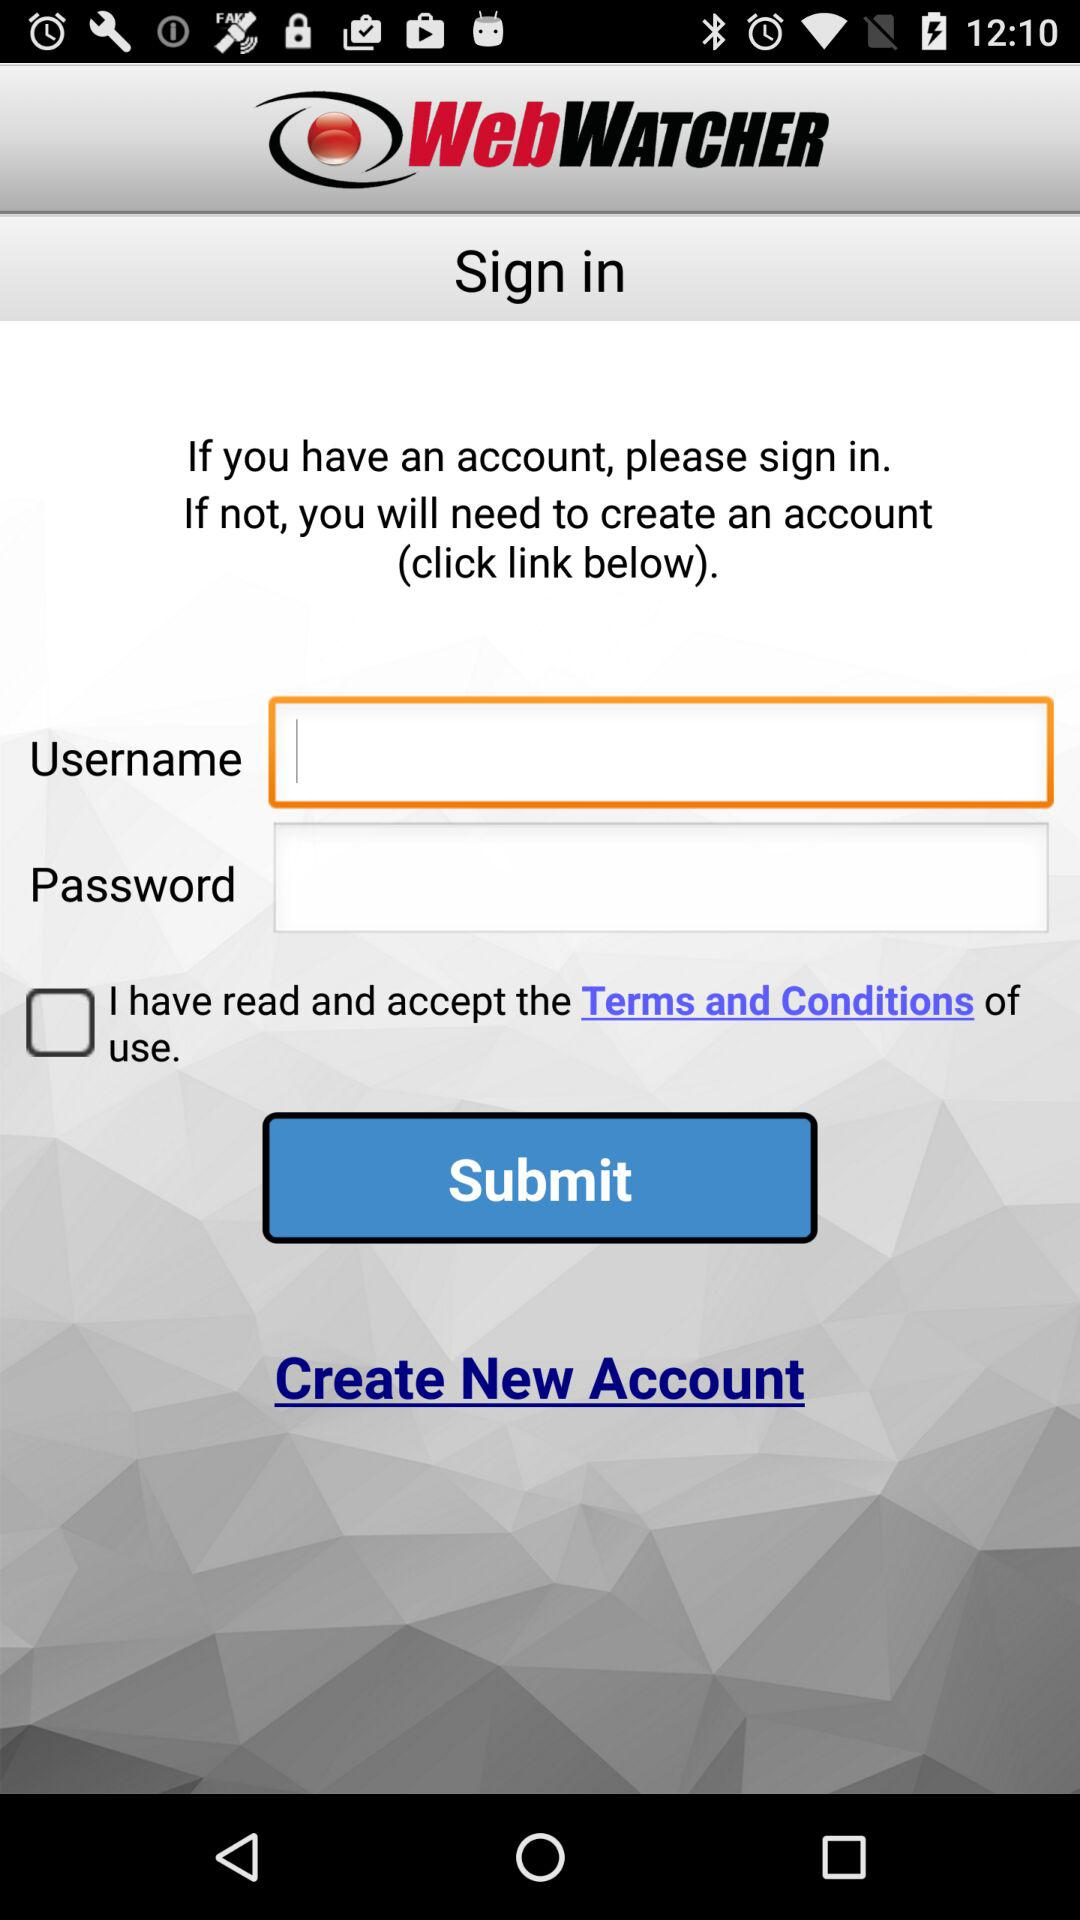How many input fields are there for signing in?
Answer the question using a single word or phrase. 2 